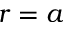<formula> <loc_0><loc_0><loc_500><loc_500>r = a</formula> 